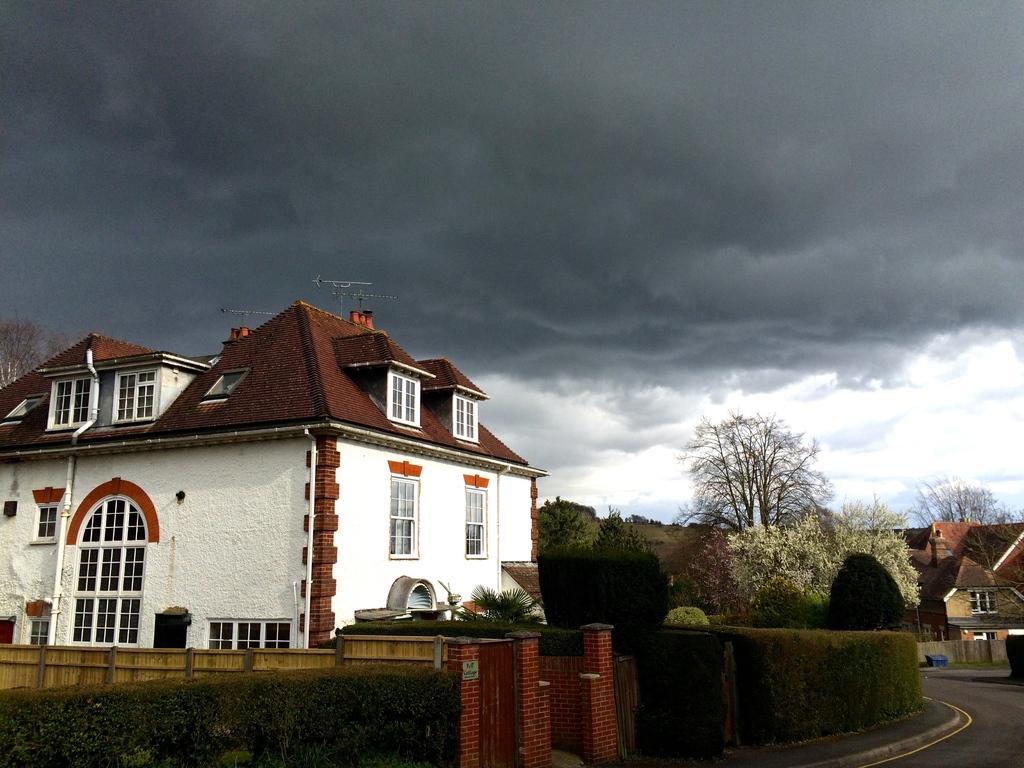Describe this image in one or two sentences. In this image we can see house which is of white and brown color there is compound wall, plants, road and in the background of the image there are some trees, houses and cloudy sky. 